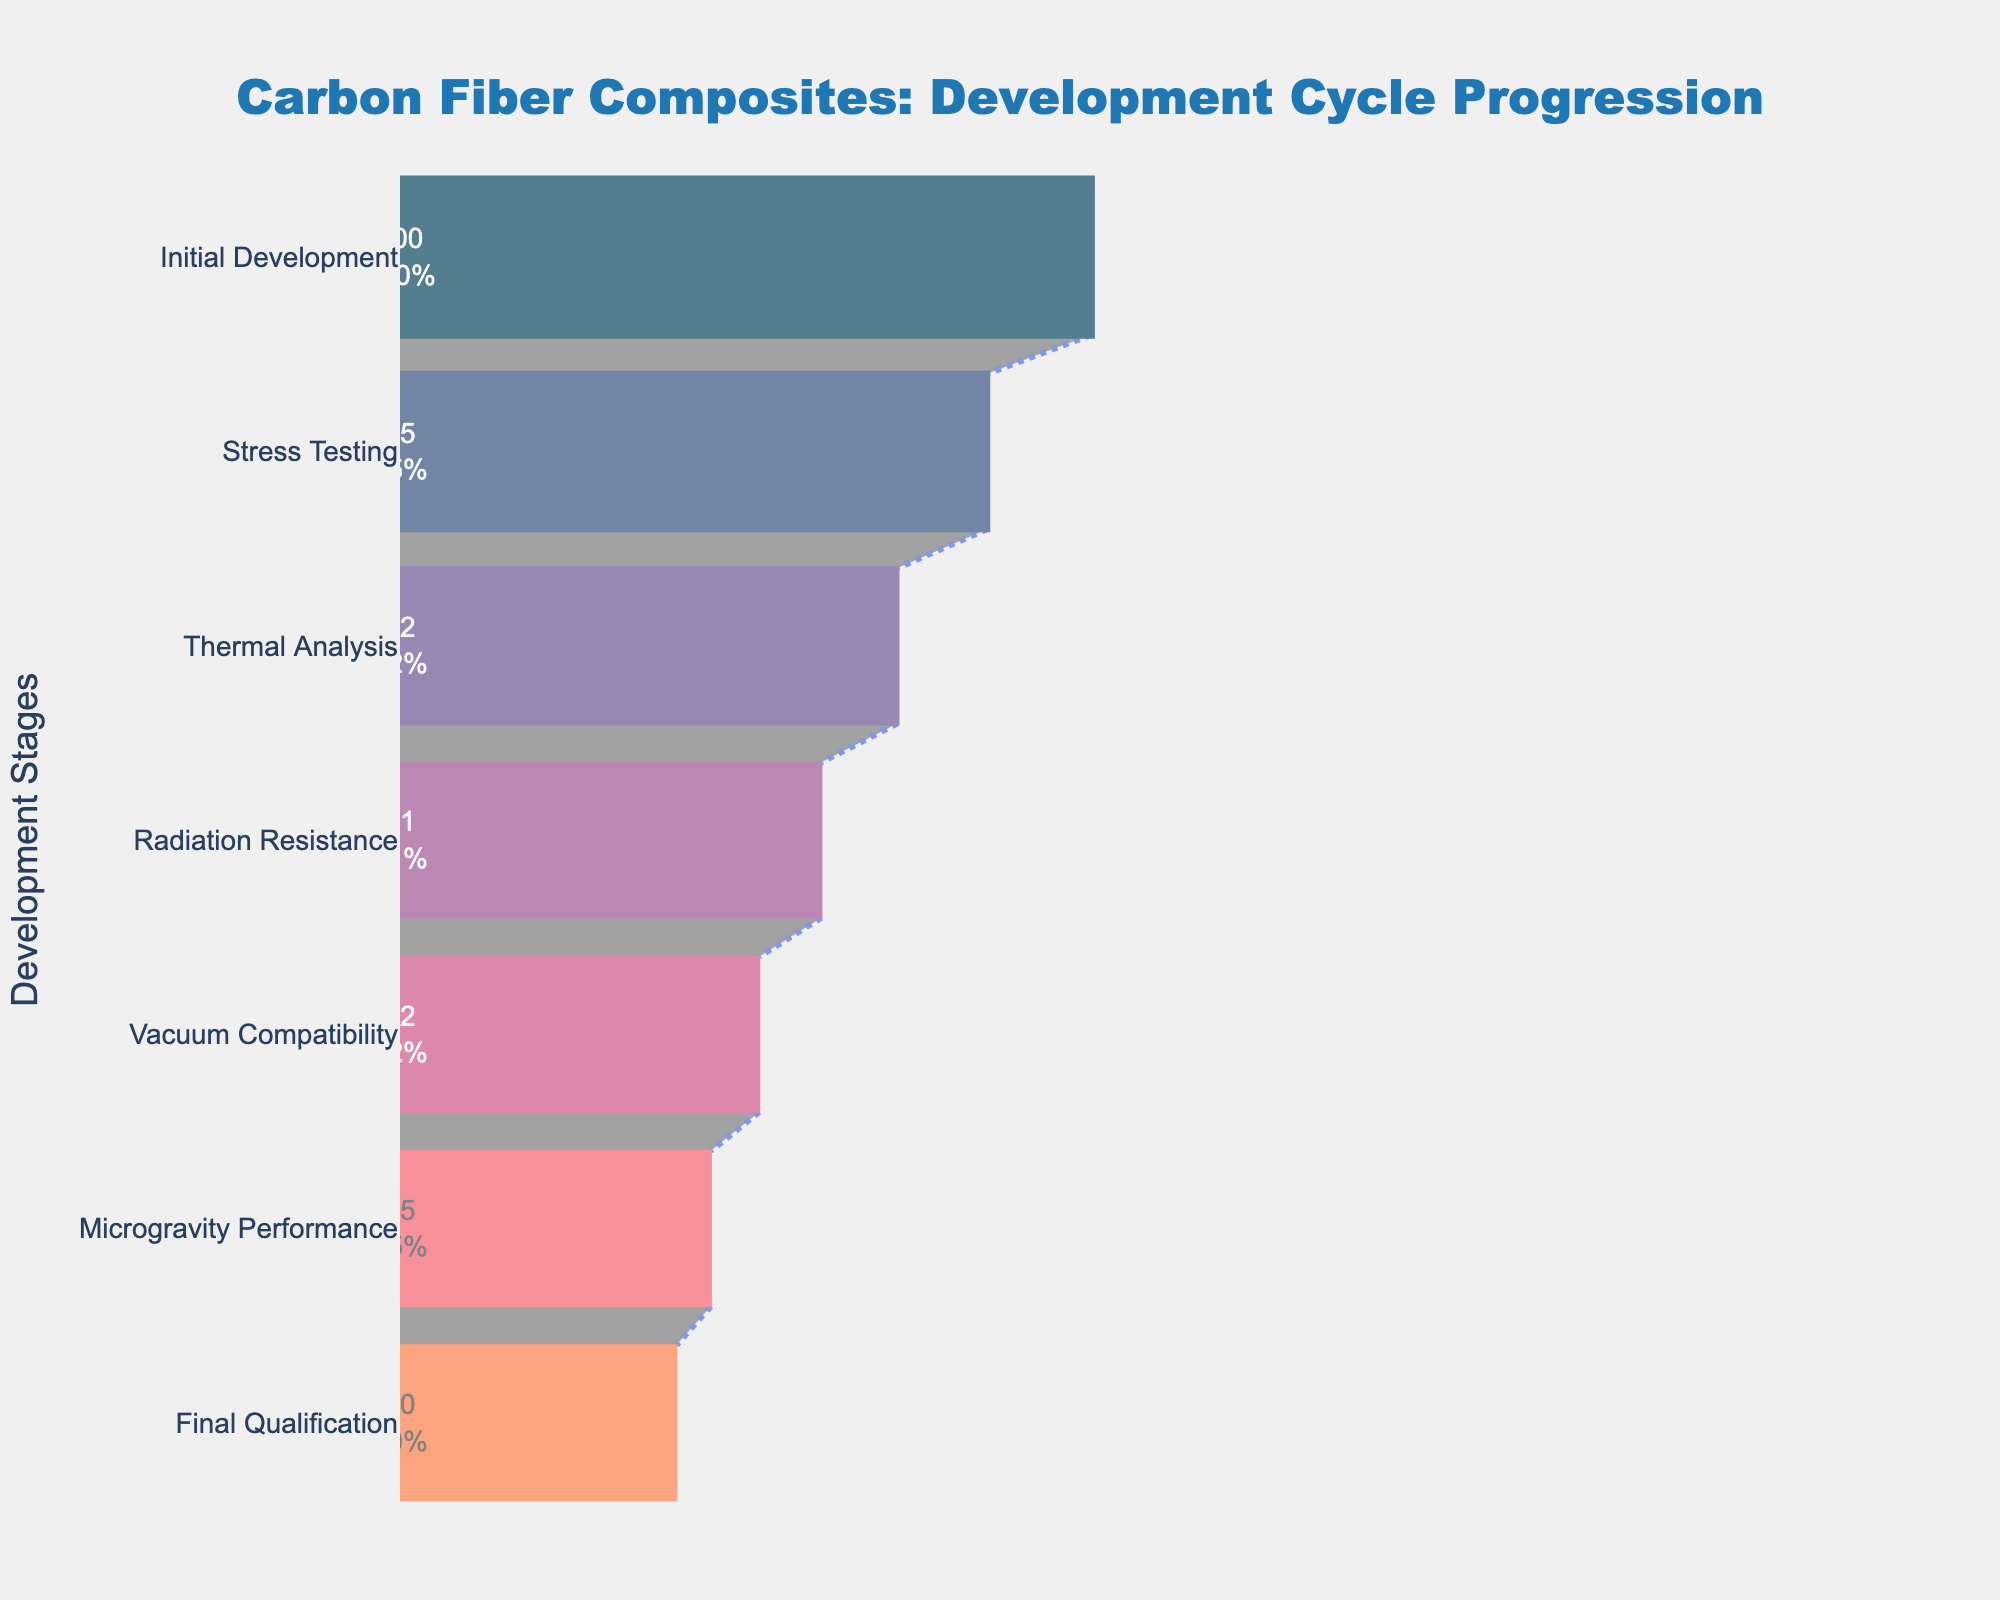What's the title of the figure? The title of the figure is usually displayed at the top; in this case, it reads "Carbon Fiber Composites: Development Cycle Progression."
Answer: Carbon Fiber Composites: Development Cycle Progression What is the initial improvement percentage for Carbon Fiber Composites? The initial improvement percentage is the first value in the funnel chart for the Initial Development stage.
Answer: 100 What is the last stage shown in the figure? The last stage is typically the final entry in the funnel chart; here it's "Final Qualification."
Answer: Final Qualification By how much does the improvement percentage decrease from the "Stress Testing" to the "Thermal Analysis" stage? To find the decrease, subtract the improvement percentage for "Thermal Analysis" from that of "Stress Testing" (85 - 72).
Answer: 13 Which stage has the lowest improvement percentage? The stage with the lowest improvement percentage is at the narrowest part of the funnel—a value of 40%—which corresponds to "Final Qualification."
Answer: Final Qualification How many stages are there in the progression? Count the number of unique stages listed on the y-axis.
Answer: 7 What percentage improvement remains after the "Radiation Resistance" stage? Look at the improvement percentage corresponding to the "Radiation Resistance" stage.
Answer: 61 What is the average improvement percentage across all stages? Add all improvement percentages and divide by the number of stages: (100 + 85 + 72 + 61 + 52 + 45 + 40) / 7.
Answer: 65 Which stage had the greatest percentage drop, and what is the value? Calculate the drops between consecutive stages and find the maximum: (100-85=15, 85-72=13, 72-61=11, 61-52=9, 52-45=7, 45-40=5). The greatest drop is from "Initial Development" to "Stress Testing" (100 to 85).
Answer: Initial Development to Stress Testing, 15 What percentage improvement remains after the "Microgravity Performance" stage compared to the "Initial Development" stage? After "Microgravity Performance," the percentage is 45 compared to the initial 100. Compare them directly as given in the chart.
Answer: 45% 